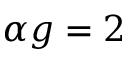Convert formula to latex. <formula><loc_0><loc_0><loc_500><loc_500>\alpha g = 2</formula> 